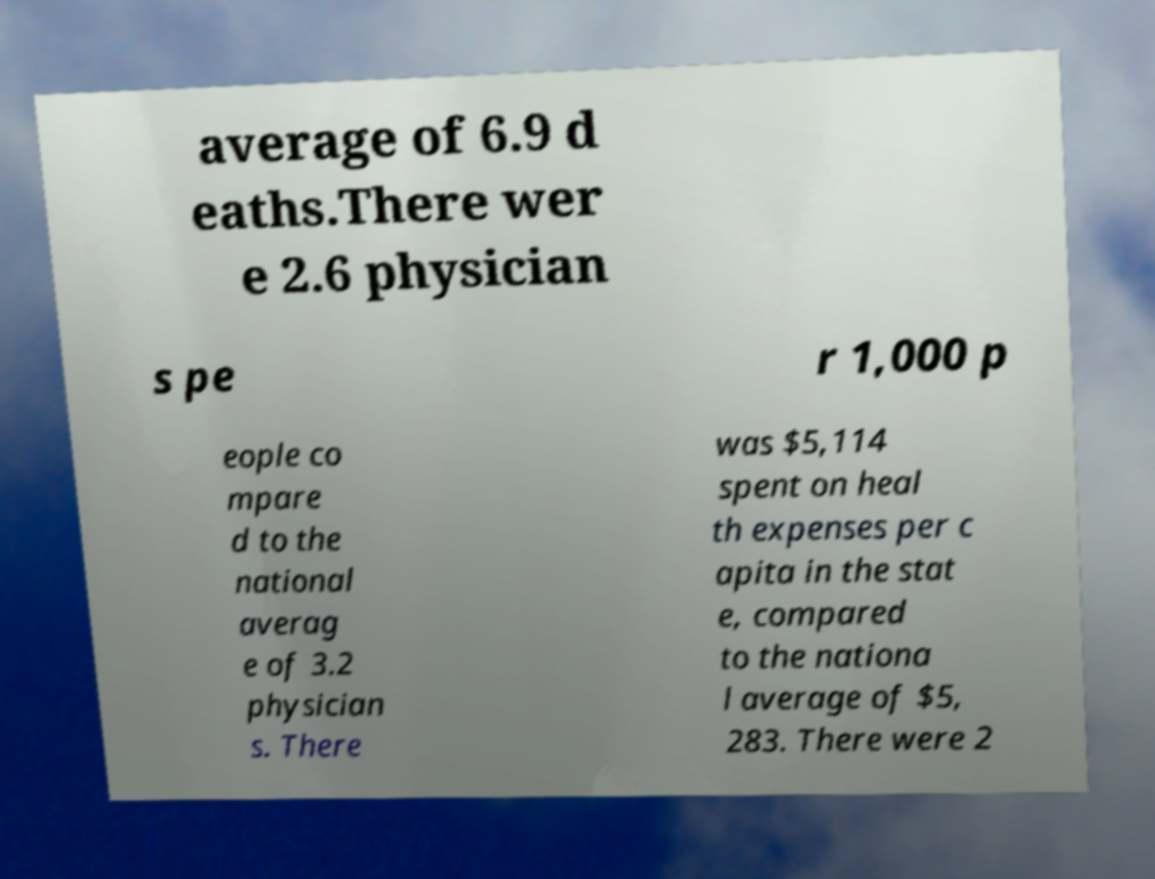What messages or text are displayed in this image? I need them in a readable, typed format. average of 6.9 d eaths.There wer e 2.6 physician s pe r 1,000 p eople co mpare d to the national averag e of 3.2 physician s. There was $5,114 spent on heal th expenses per c apita in the stat e, compared to the nationa l average of $5, 283. There were 2 